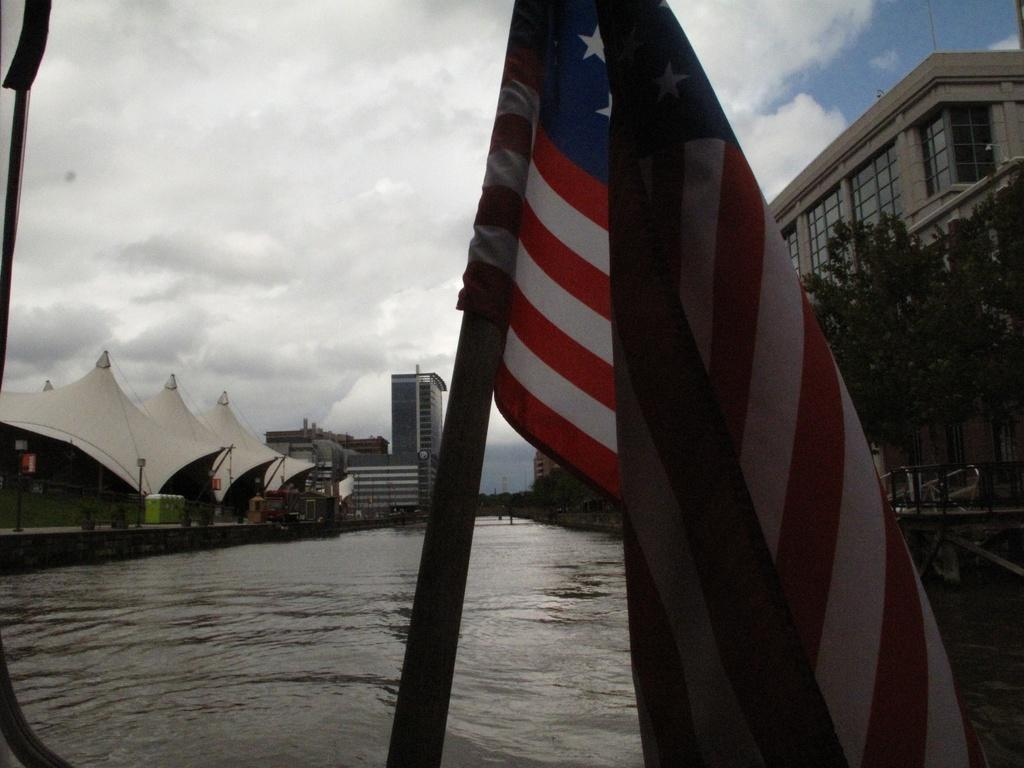What is the main subject in the center of the image? There is a flag in the center of the image. What can be seen in the background of the image? Sky, clouds, buildings, a wall, tents, glass, trees, and poles are visible in the background of the image. Additionally, water is visible in the background. Can you describe the unspecified object in the left corner of the image? Unfortunately, the facts provided do not give any information about the unspecified object in the left corner of the image. What type of fruit is hanging from the trees in the background of the image? There is no fruit visible in the image, as the facts provided only mention the presence of trees in the background. 